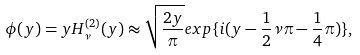<formula> <loc_0><loc_0><loc_500><loc_500>\phi ( y ) = y H _ { \nu } ^ { ( 2 ) } ( y ) \approx \sqrt { \frac { 2 y } { \pi } } e x p \{ i ( y - \frac { 1 } { 2 } \nu \pi - \frac { 1 } { 4 } \pi ) \} ,</formula> 